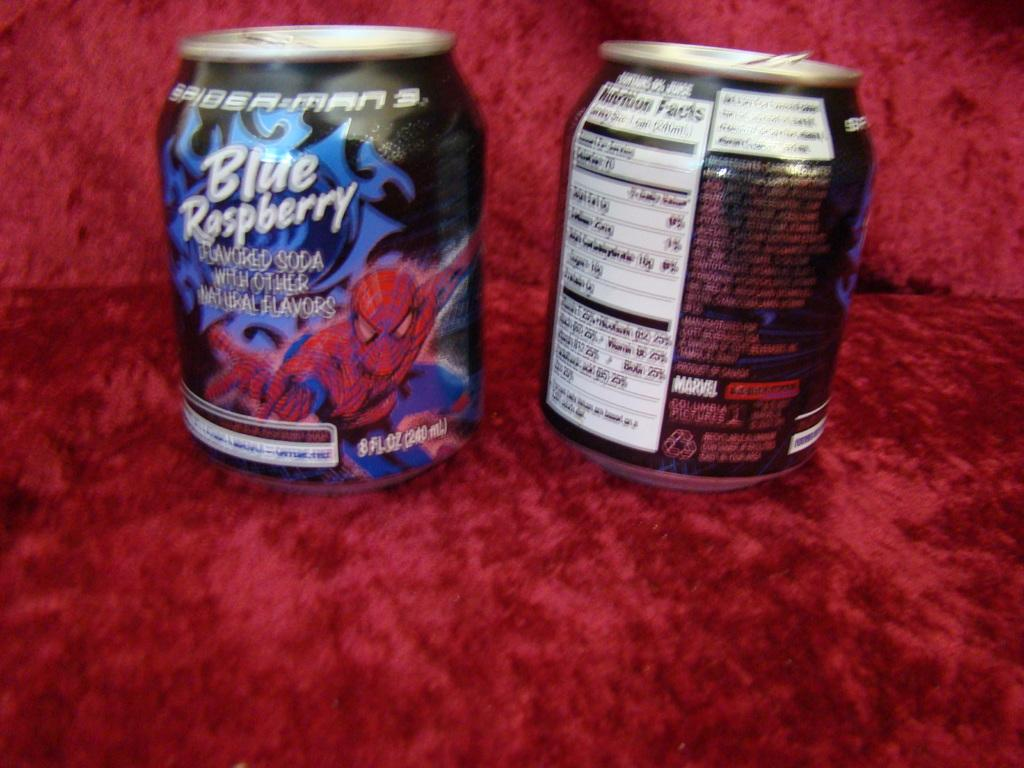<image>
Render a clear and concise summary of the photo. A beverage appears to be a promotional item for the movie Spider-Man 3. 